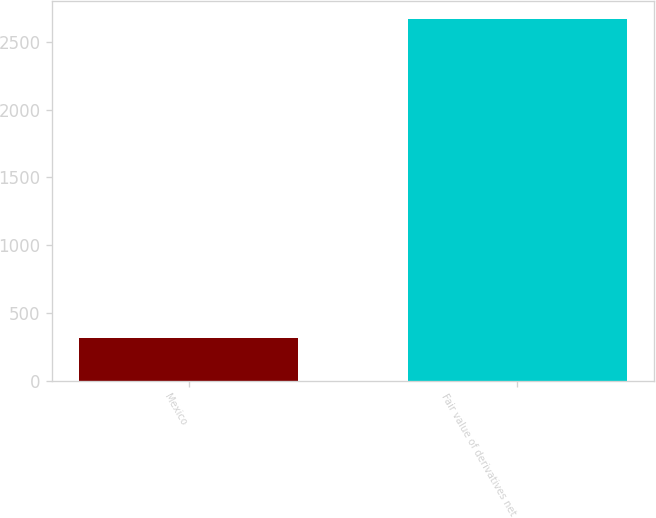Convert chart. <chart><loc_0><loc_0><loc_500><loc_500><bar_chart><fcel>Mexico<fcel>Fair value of derivatives net<nl><fcel>316<fcel>2670<nl></chart> 